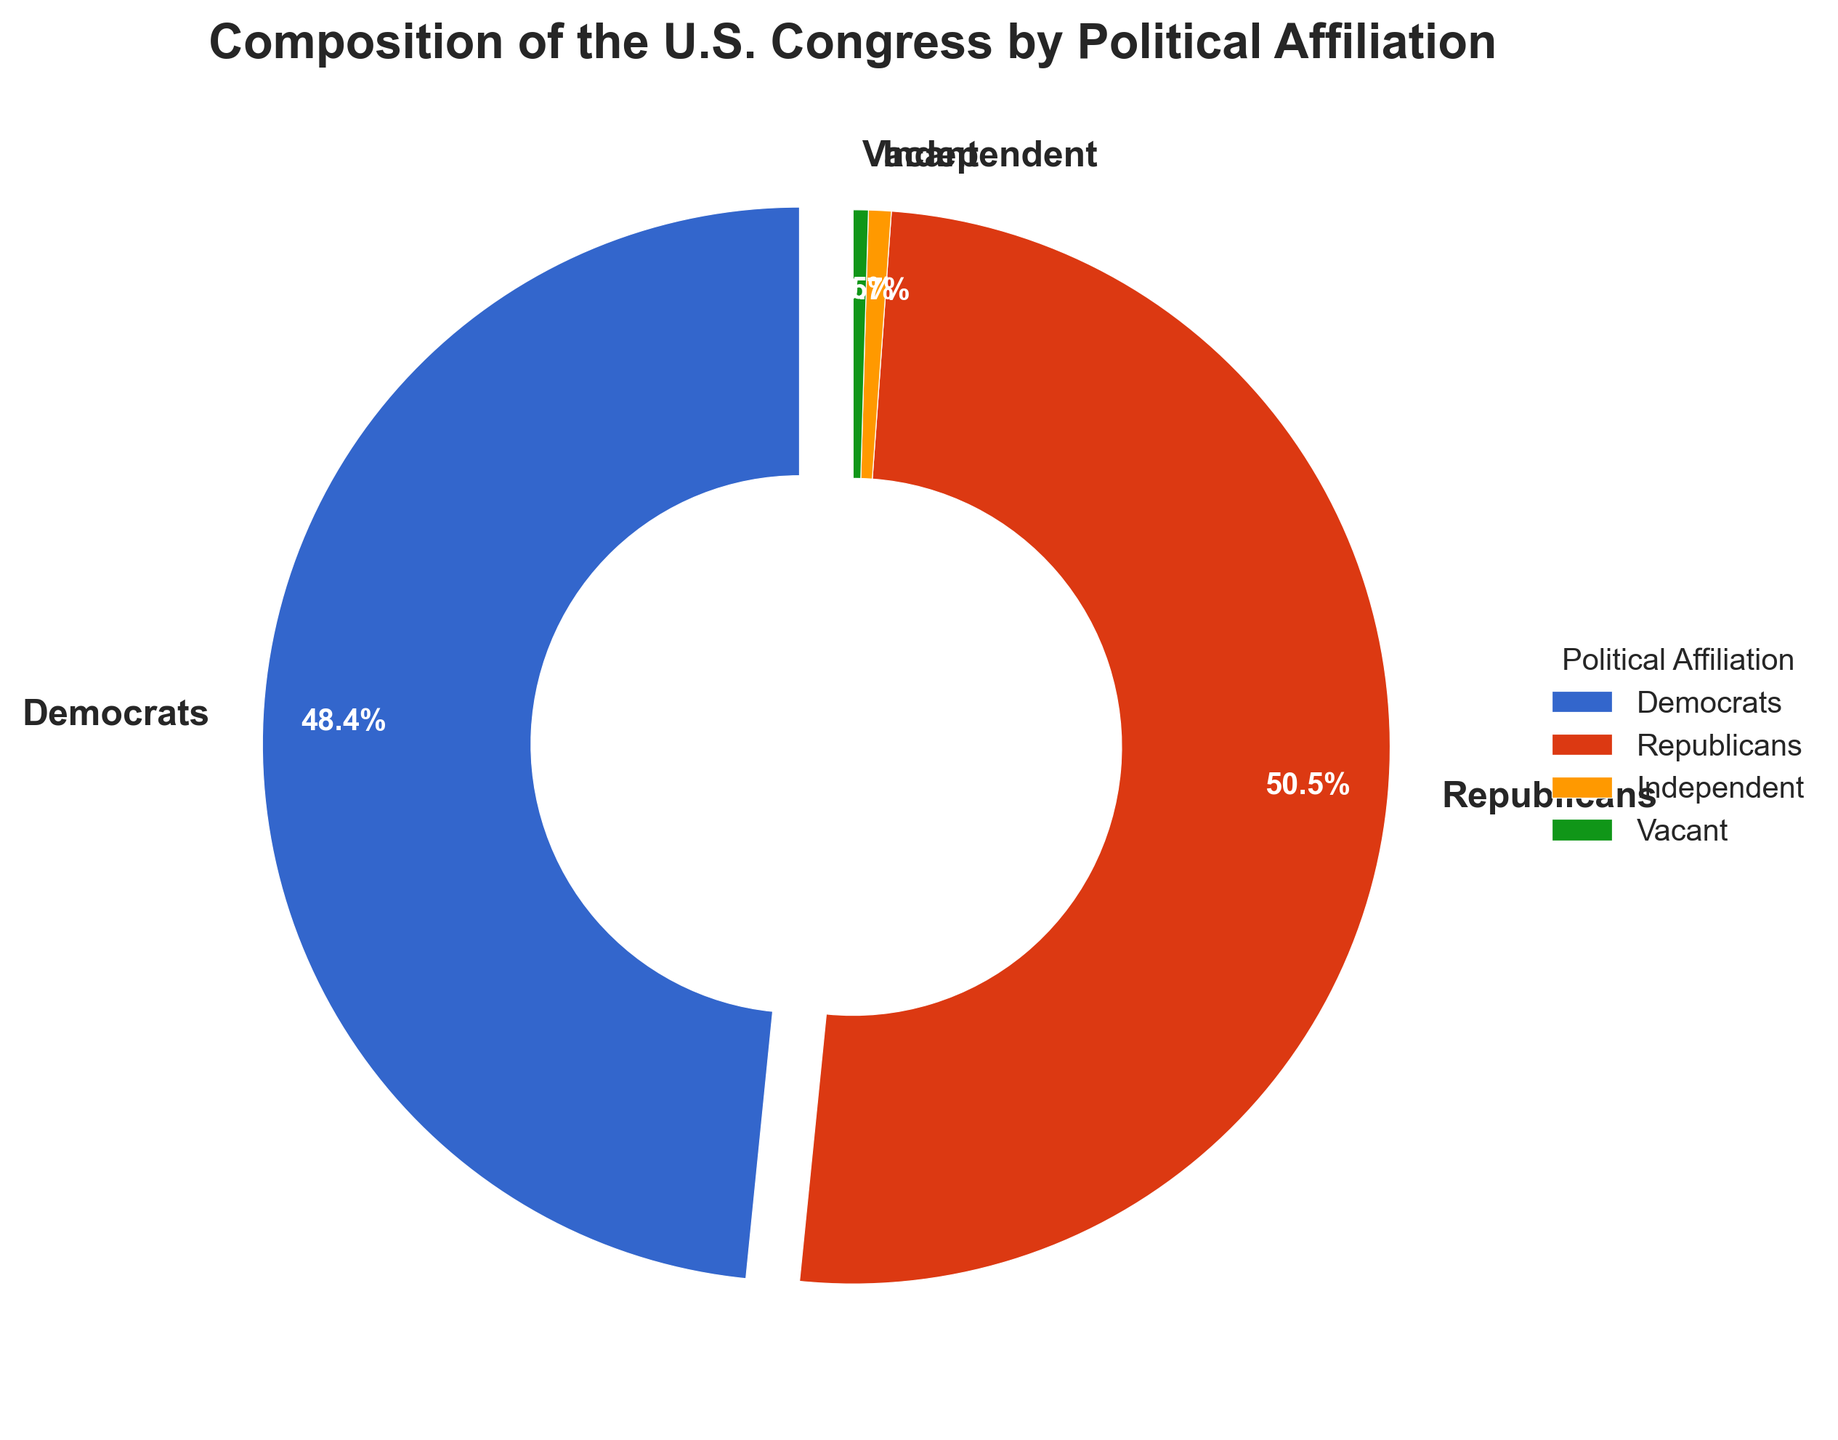What percentage of members are Democrats? From the figure, we can see that the slice labeled "Democrats" shows 213 members. The total number of members is the sum of all categories: 213 (Democrats) + 222 (Republicans) + 3 (Independent) + 2 (Vacant) = 440. The percentage of Democrats is calculated as (213/440) * 100% ≈ 48.4%.
Answer: 48.4% Which political affiliation has the largest number of members? By comparing the sizes of the slices, the "Republicans" slice is the largest. The number of members in each affiliation confirms this: 222 (Republicans), which is greater than the numbers for Democrats, Independent, and Vacant.
Answer: Republicans Which affiliation has the smallest representation in the Congress? The smallest slice belongs to the "Independent" category with 3 members. This is smaller than the number of members in the other affiliations.
Answer: Independent What is the difference in the number of members between Republicans and Democrats? The number of Republican members is 222, and the number of Democrat members is 213. The difference is 222 - 213 = 9.
Answer: 9 What proportion of Congress is made up by Independents and Vacant seats combined? The combined number of Independents and Vacant seats is 3 (Independent) + 2 (Vacant) = 5. The total number of Congress members is 440. The proportion is (5/440) * 100% ≈ 1.1%.
Answer: 1.1% How many more Republicans are there than Independents? With 222 Republicans and 3 Independents, the difference is 222 - 3 = 219.
Answer: 219 Which affiliation is represented by the blue slice in the pie chart? Referring to the colors mentioned in the function, the blue color corresponds to the first category, which is "Democrats".
Answer: Democrats If the Vacant seats were filled equally by Democrats and Republicans, what would be the new number of members for each? There are 2 Vacant seats. If they are equally filled by Democrats and Republicans, each would get 1 seat. Thus, Democrats would have 213 + 1 = 214, and Republicans would have 222 + 1 = 223.
Answer: 214 (Democrats), 223 (Republicans) What is the visual effect applied to the Democrats' slice? The Democrats' slice is slightly separated from the center of the pie chart, indicating an "explode" effect to highlight it.
Answer: explode effect If the Vacant seats were filled by adding one Independent and one Democrat, what would be the new percentage for the Independents? Adding one seat to the Independents makes 3 + 1 = 4 Independents. The new total number of Congress members becomes 440 + 1 = 441 as only one seat is considered here. The new percentage is (4/441) * 100% ≈ 0.9%.
Answer: 0.9% 